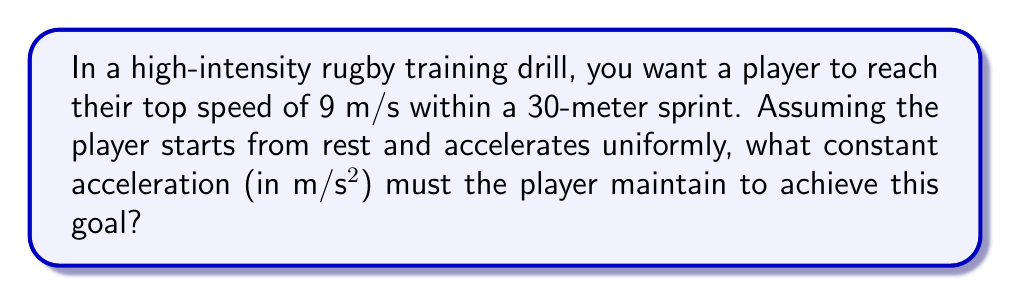Could you help me with this problem? To solve this problem, we'll use the equations of motion for constant acceleration. Let's break it down step-by-step:

1) We know:
   - Initial velocity, $v_0 = 0$ m/s (starting from rest)
   - Final velocity, $v = 9$ m/s (top speed)
   - Distance, $s = 30$ m
   - We need to find acceleration, $a$

2) We'll use the equation:
   $$ v^2 = v_0^2 + 2as $$

3) Substituting our known values:
   $$ 9^2 = 0^2 + 2a(30) $$

4) Simplify:
   $$ 81 = 60a $$

5) Solve for $a$:
   $$ a = \frac{81}{60} = 1.35 \text{ m/s}^2 $$

This acceleration will allow the player to reach top speed exactly at the 30-meter mark. It's important to note that in a real rugby scenario, players might accelerate more rapidly at the start and then maintain their top speed, but this constant acceleration model provides a good approximation for training purposes.
Answer: The player must maintain a constant acceleration of 1.35 m/s². 